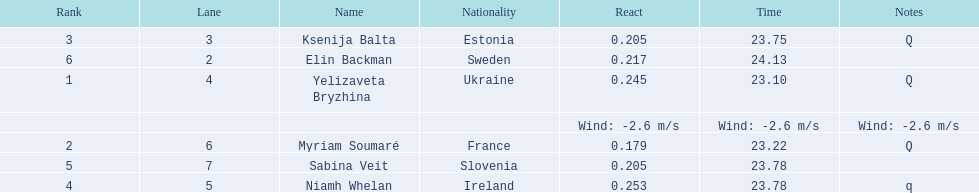The difference between yelizaveta bryzhina's time and ksenija balta's time? 0.65. Can you parse all the data within this table? {'header': ['Rank', 'Lane', 'Name', 'Nationality', 'React', 'Time', 'Notes'], 'rows': [['3', '3', 'Ksenija Balta', 'Estonia', '0.205', '23.75', 'Q'], ['6', '2', 'Elin Backman', 'Sweden', '0.217', '24.13', ''], ['1', '4', 'Yelizaveta Bryzhina', 'Ukraine', '0.245', '23.10', 'Q'], ['', '', '', '', 'Wind: -2.6\xa0m/s', 'Wind: -2.6\xa0m/s', 'Wind: -2.6\xa0m/s'], ['2', '6', 'Myriam Soumaré', 'France', '0.179', '23.22', 'Q'], ['5', '7', 'Sabina Veit', 'Slovenia', '0.205', '23.78', ''], ['4', '5', 'Niamh Whelan', 'Ireland', '0.253', '23.78', 'q']]} 